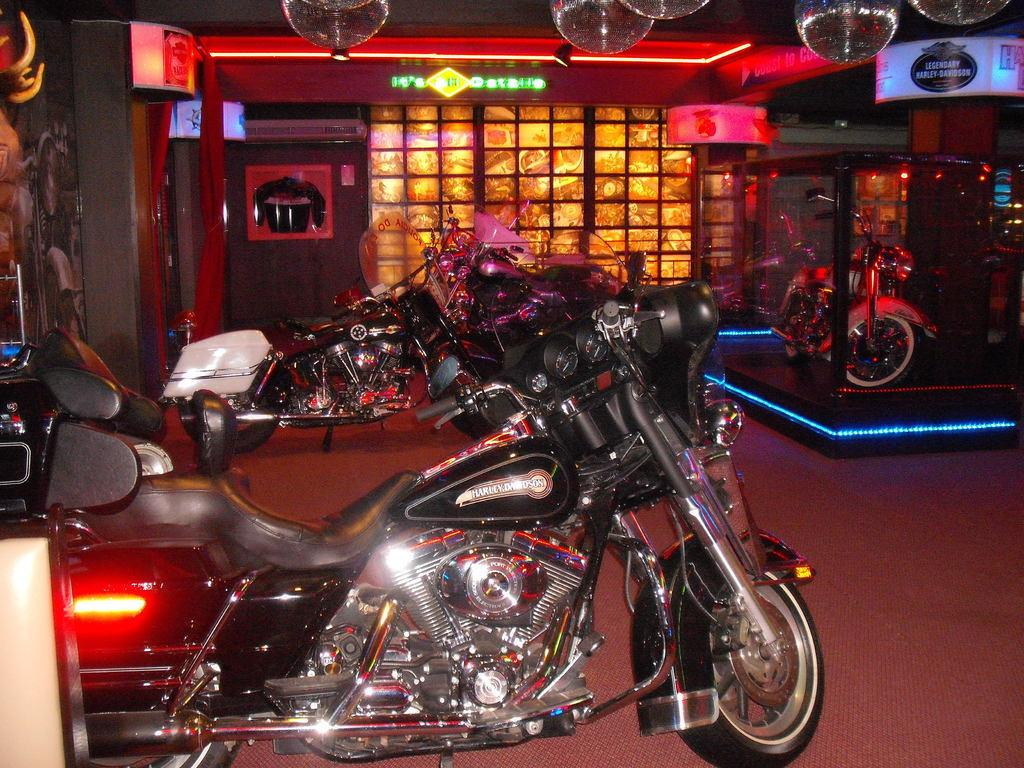What type of vehicles are present in the image? There are motorcycles in the image. What else can be seen in the image besides the motorcycles? There are lights and hoardings in the image. What is the value of the camp in the image? There is no camp present in the image, so it is not possible to determine its value. 